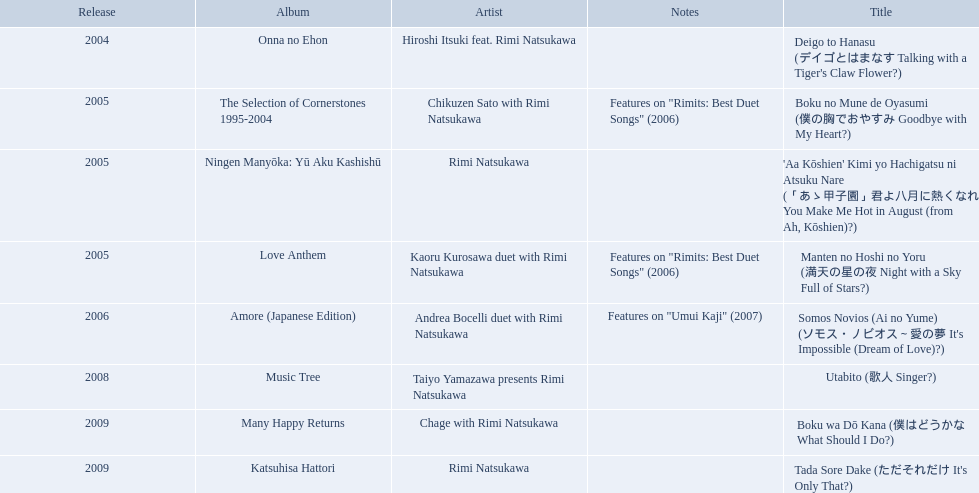What are the notes for sky full of stars? Features on "Rimits: Best Duet Songs" (2006). What other song features this same note? Boku no Mune de Oyasumi (僕の胸でおやすみ Goodbye with My Heart?). 